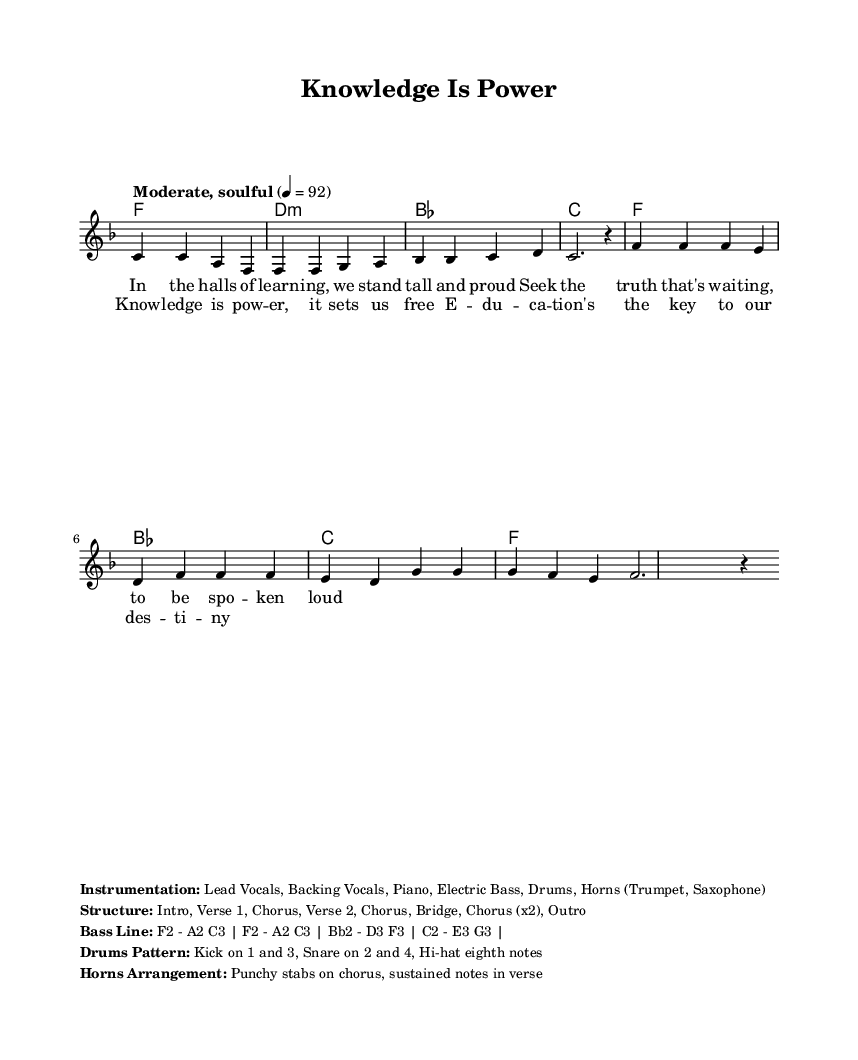What is the key signature of this music? The key signature is F major, which has one flat (B flat). We can identify this by examining the key signature notations on the staff at the beginning of the piece.
Answer: F major What is the time signature of this music? The time signature is 4/4, which is displayed at the beginning of the piece. This indicates four beats per measure, and each quarter note gets one beat.
Answer: 4/4 What is the tempo marking for this piece? The tempo marking is "Moderate, soulful" with a metronome marking of 92 quarter notes per minute. This informs us how fast the music should be played.
Answer: Moderate, soulful How many verses are in the song structure? The structure includes two verses as indicated in the outlined organization of the sections of the song. Each verse is followed by a chorus, and they occur in a repeated pattern.
Answer: 2 What is the purpose of the horns arrangement in this music? The horns arrangement specifies "Punchy stabs on chorus, sustained notes in verse." This indicates that during the chorus, the horns should play short, strong accents, while in the verses, they should hold notes longer to complement the melody.
Answer: Punchy stabs What instrument plays a consistent kick pattern on beats 1 and 3? The drums play a consistent kick pattern on beats 1 and 3, as described in the provided section detailing the drums pattern. This specifies the rhythmic foundation for the piece and drives its overall groove.
Answer: Drums What is the key message expressed in the lyrics of the chorus? The key message in the chorus lyrics is that knowledge is power and education is essential for achieving one's destiny. This is evident in phrases emphasizing the importance of knowledge and education, encapsulating the song's uplifting theme.
Answer: Knowledge is power 